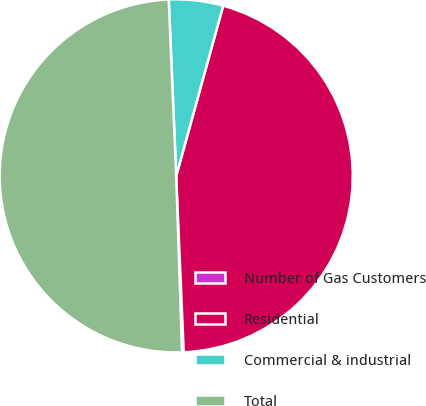<chart> <loc_0><loc_0><loc_500><loc_500><pie_chart><fcel>Number of Gas Customers<fcel>Residential<fcel>Commercial & industrial<fcel>Total<nl><fcel>0.15%<fcel>45.04%<fcel>4.96%<fcel>49.85%<nl></chart> 